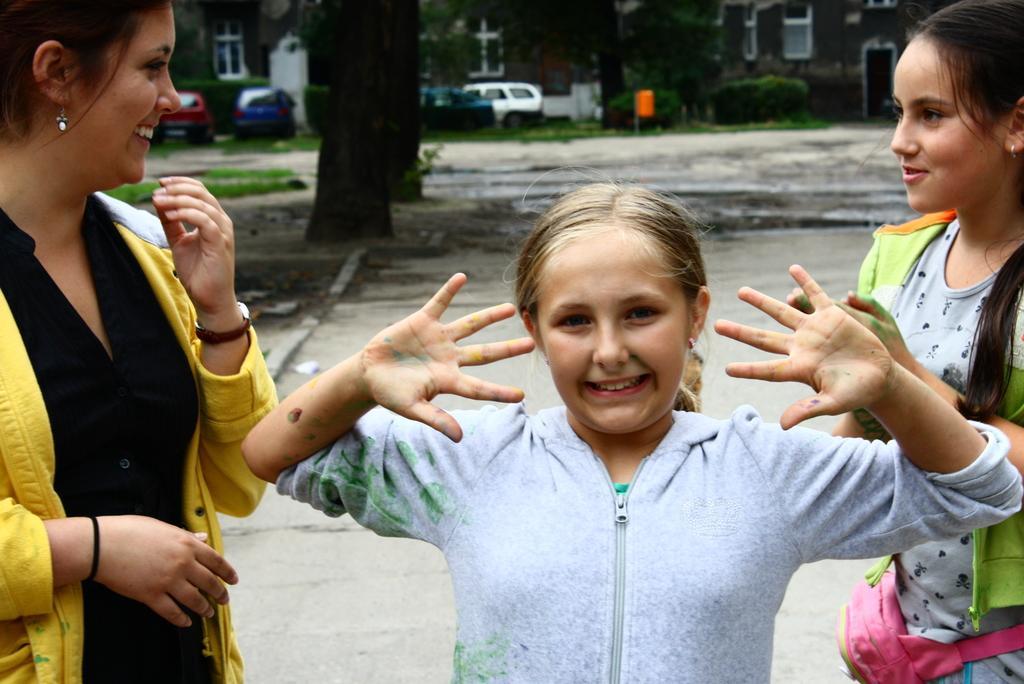Please provide a concise description of this image. This picture is clicked outside. In the foreground we can see the group of women standing on the ground. In the background we can see the buildings, plants, trees, vehicles, green grass, ground and the trunks of the trees and the windows. 